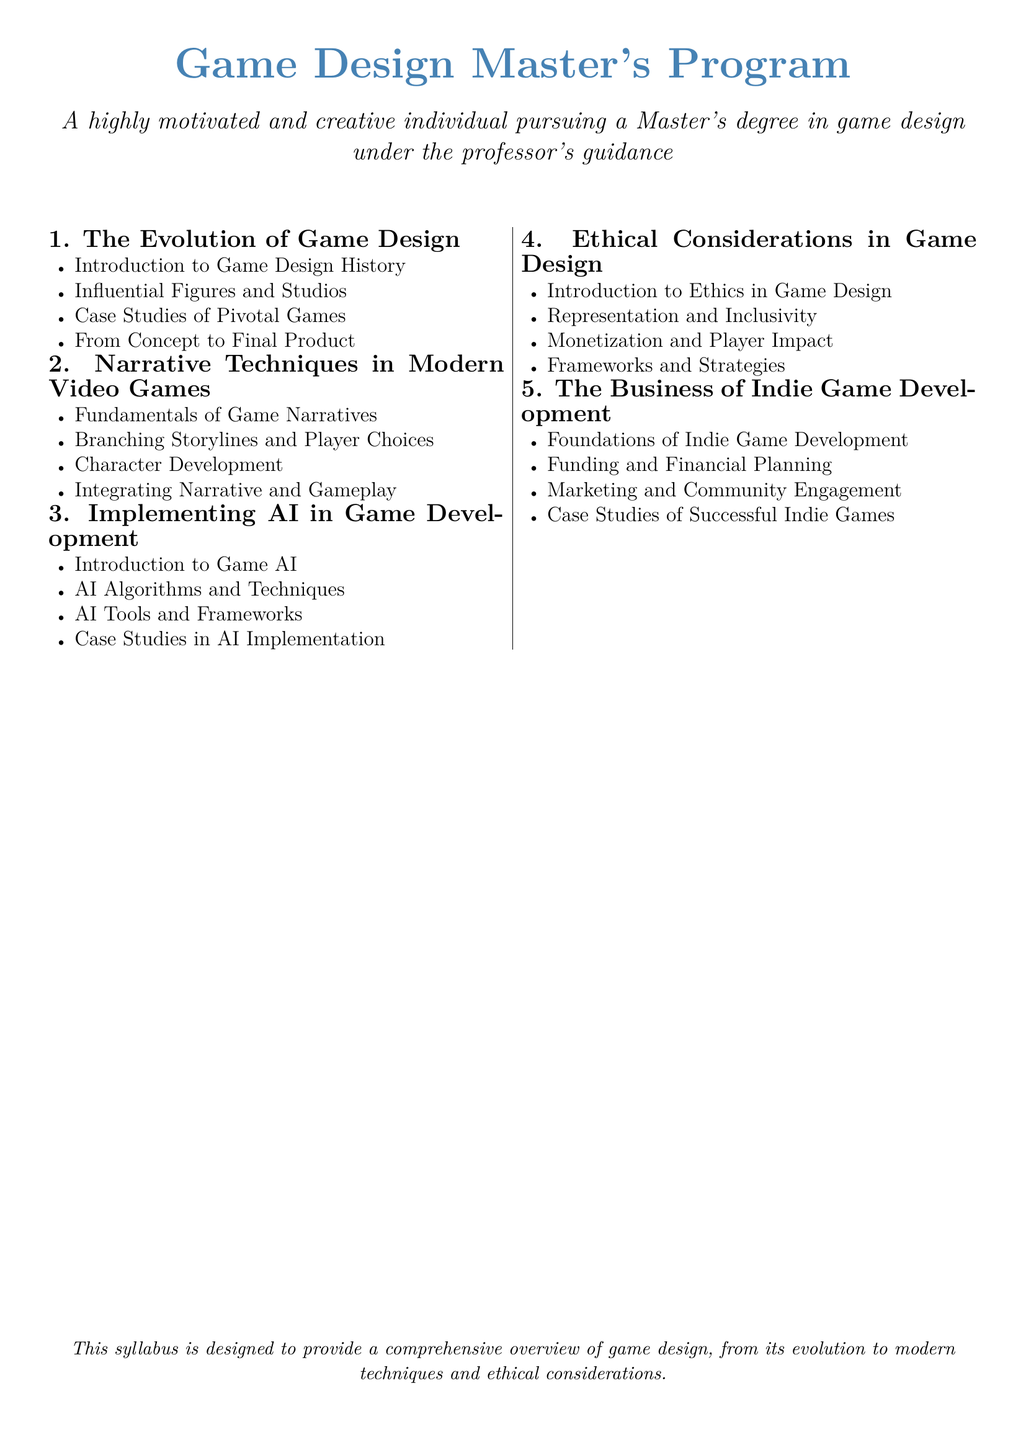What is the first module in the syllabus? The first module listed in the syllabus focuses on the evolution of game design from concept to completion.
Answer: The Evolution of Game Design How many main modules are there? There are a total of five main modules outlined in the syllabus.
Answer: Five Which module discusses monetization practices? The module that explores ethical considerations in game design addresses monetization practices.
Answer: Ethical Considerations in Game Design What is one topic covered in the module about narrative techniques? The module on narrative techniques includes a focus on branching storylines.
Answer: Branching Storylines What does the third module analyze regarding AI? The third module analyzes the role of artificial intelligence and its practical applications in game development.
Answer: AI in Game Development Which module includes case studies of successful indie games? The module that covers the business of indie game development includes case studies of successful indie games.
Answer: The Business of Indie Game Development What is a focus area in the ethical considerations module? The ethical considerations module includes a focus on representation and inclusivity.
Answer: Representation and Inclusivity Which aspect of game development is covered in the module on AI? The module on AI covers AI algorithms and techniques used in game development.
Answer: AI Algorithms and Techniques 